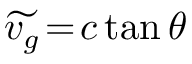Convert formula to latex. <formula><loc_0><loc_0><loc_500><loc_500>\widetilde { v _ { g } } \, = \, c \, t a n \, \theta</formula> 